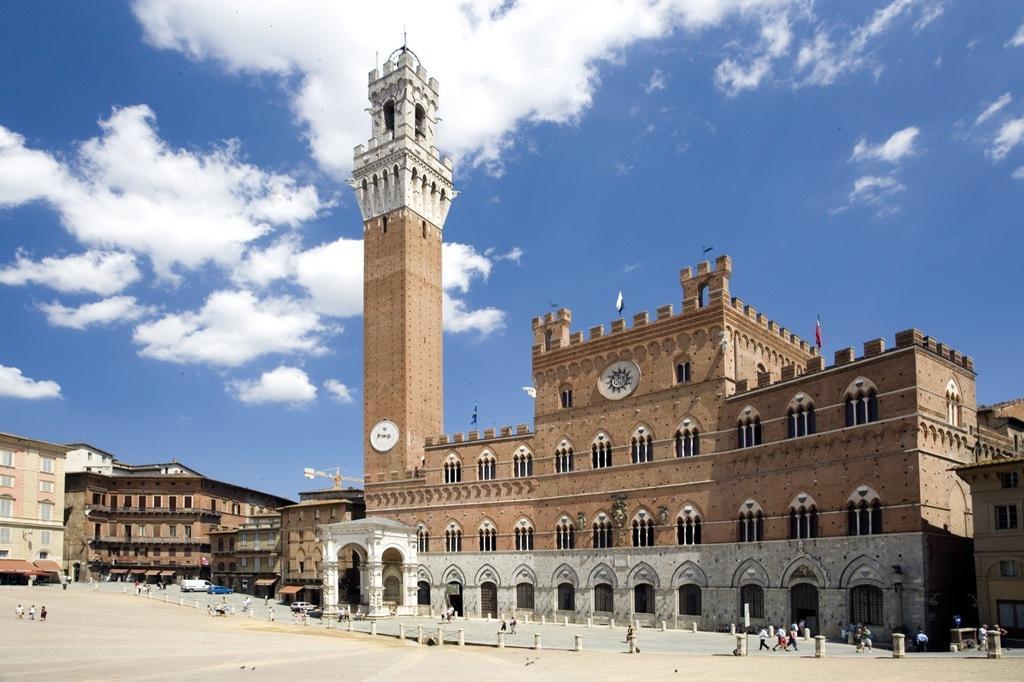How would you summarize this image in a sentence or two? In this image, we can see buildings, tower, walls, pillars and windows. Here we can see few flags. At the bottom of the image, we can see few people. Background there is a sky. 